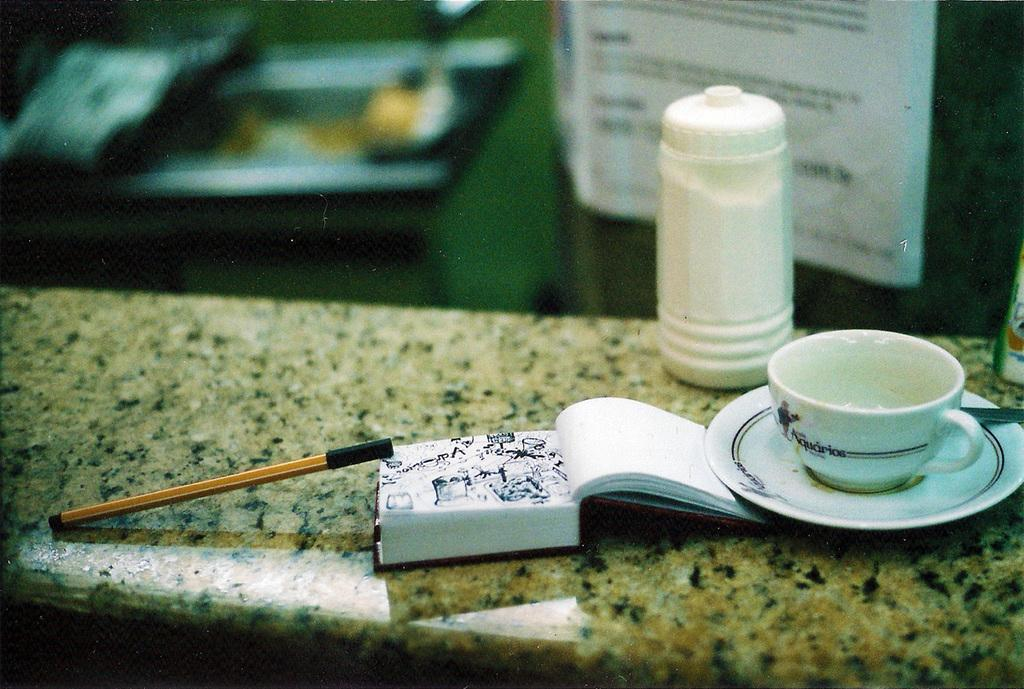What object related to reading can be seen in the image? There is a book in the image. What writing instrument is present in the image? There is a pen in the image. What type of container is visible in the image? There is a cup in the image. What is another object used for holding food or other items in the image? There is a plate in the image. What type of transport is visible in the image? There is no transport present in the image. What kind of apparatus is used for conducting experiments in the image? There is no apparatus present in the image. 